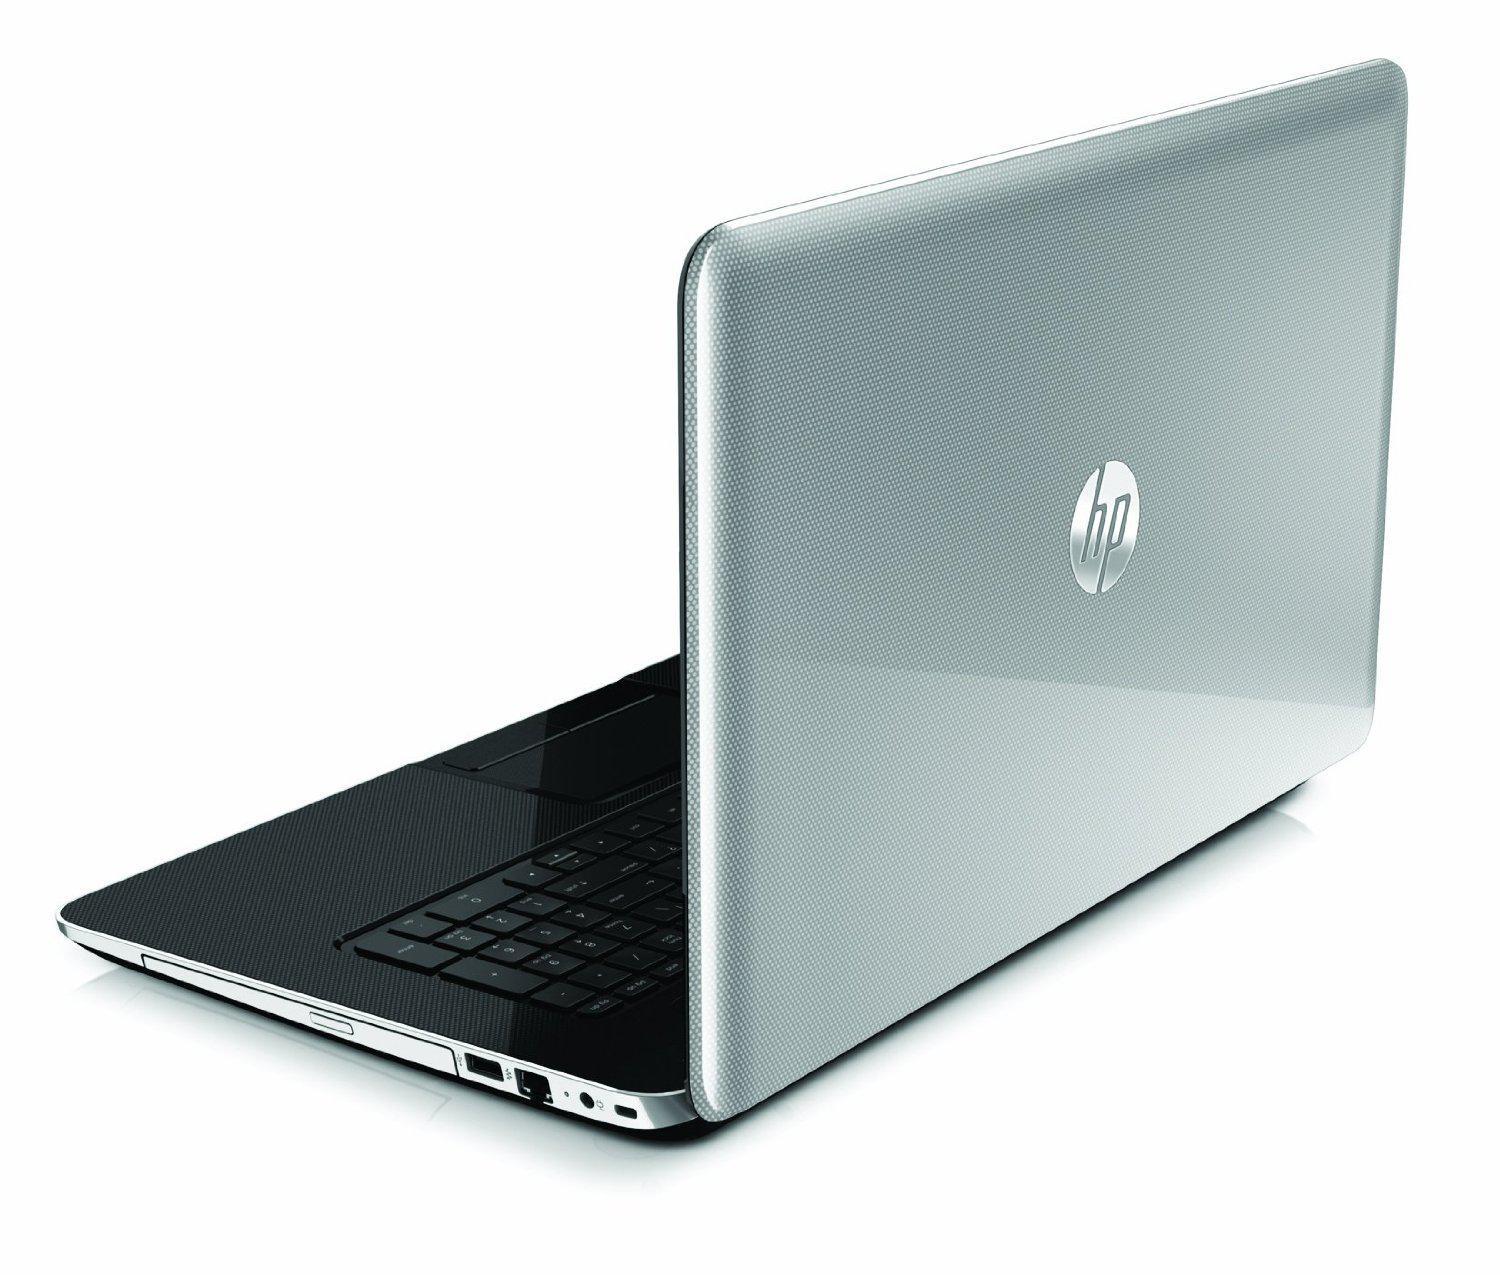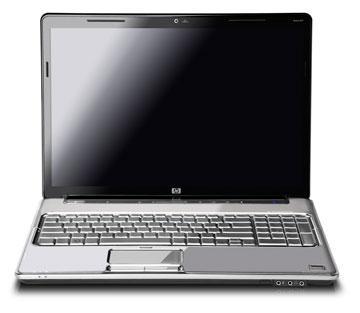The first image is the image on the left, the second image is the image on the right. For the images displayed, is the sentence "One laptop is facing directly forward, and another laptop is facing diagonally backward." factually correct? Answer yes or no. Yes. The first image is the image on the left, the second image is the image on the right. Considering the images on both sides, is "One open laptop is displayed head-on, and the other open laptop is displayed at an angle with its screen facing away from the camera toward the left." valid? Answer yes or no. Yes. 